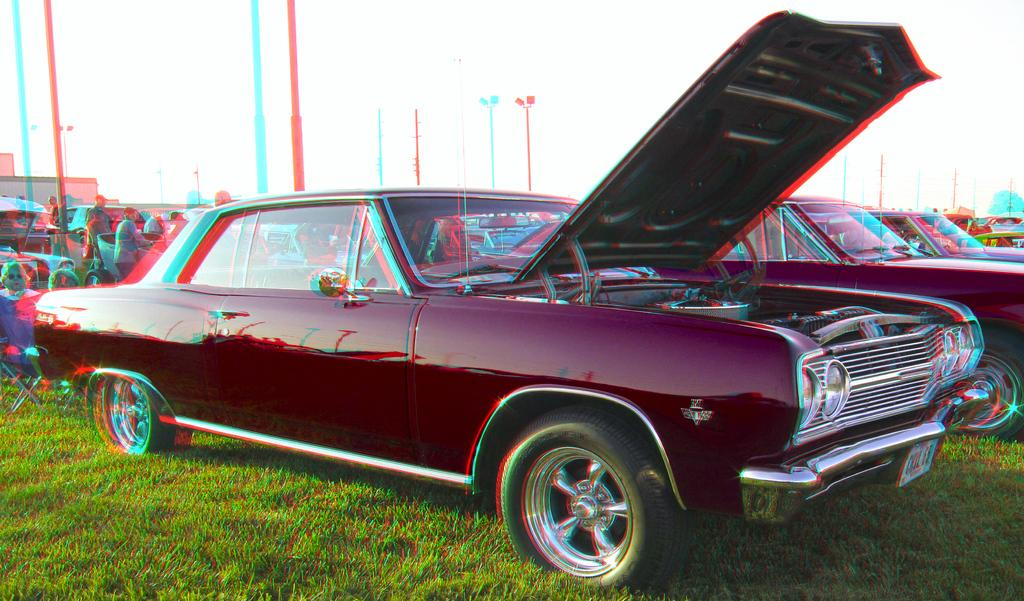What can be observed about the image's appearance? The image is edited. What is located in the foreground of the image? There are cars in the foreground. Where are the cars parked? The cars are parked on the grass. What can be seen behind the cars? There are people behind the cars. What type of rhythm is being played by the plough in the image? There is no plough or rhythm present in the image. 